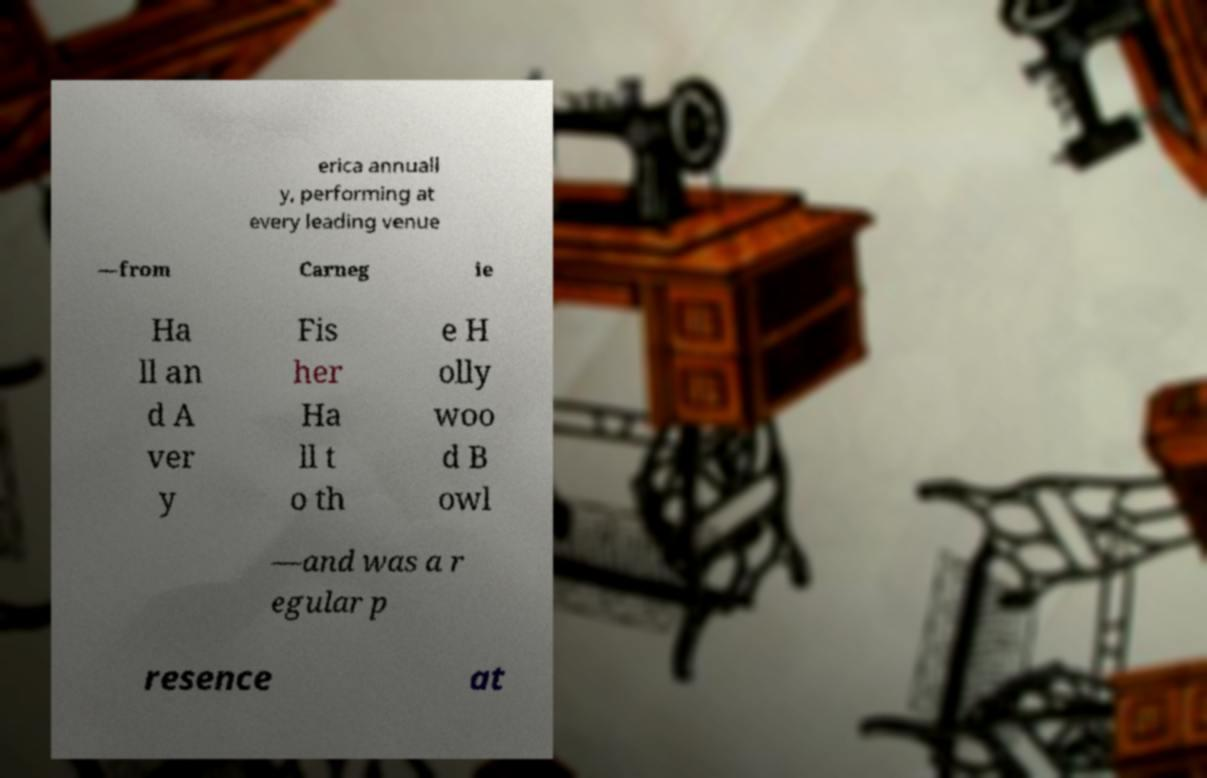For documentation purposes, I need the text within this image transcribed. Could you provide that? erica annuall y, performing at every leading venue —from Carneg ie Ha ll an d A ver y Fis her Ha ll t o th e H olly woo d B owl —and was a r egular p resence at 